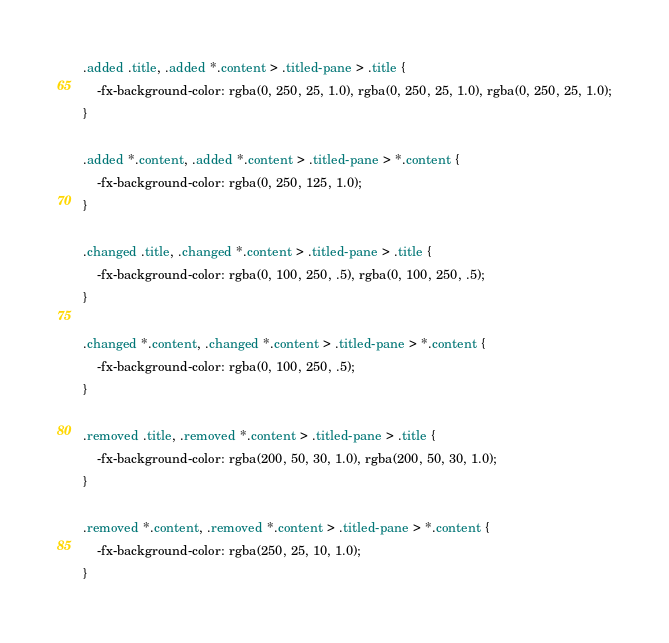<code> <loc_0><loc_0><loc_500><loc_500><_CSS_>.added .title, .added *.content > .titled-pane > .title {
	-fx-background-color: rgba(0, 250, 25, 1.0), rgba(0, 250, 25, 1.0), rgba(0, 250, 25, 1.0);
}

.added *.content, .added *.content > .titled-pane > *.content {
	-fx-background-color: rgba(0, 250, 125, 1.0);
}

.changed .title, .changed *.content > .titled-pane > .title {
	-fx-background-color: rgba(0, 100, 250, .5), rgba(0, 100, 250, .5);
}

.changed *.content, .changed *.content > .titled-pane > *.content {
	-fx-background-color: rgba(0, 100, 250, .5);
}

.removed .title, .removed *.content > .titled-pane > .title {
	-fx-background-color: rgba(200, 50, 30, 1.0), rgba(200, 50, 30, 1.0);
}

.removed *.content, .removed *.content > .titled-pane > *.content {
	-fx-background-color: rgba(250, 25, 10, 1.0);
}</code> 